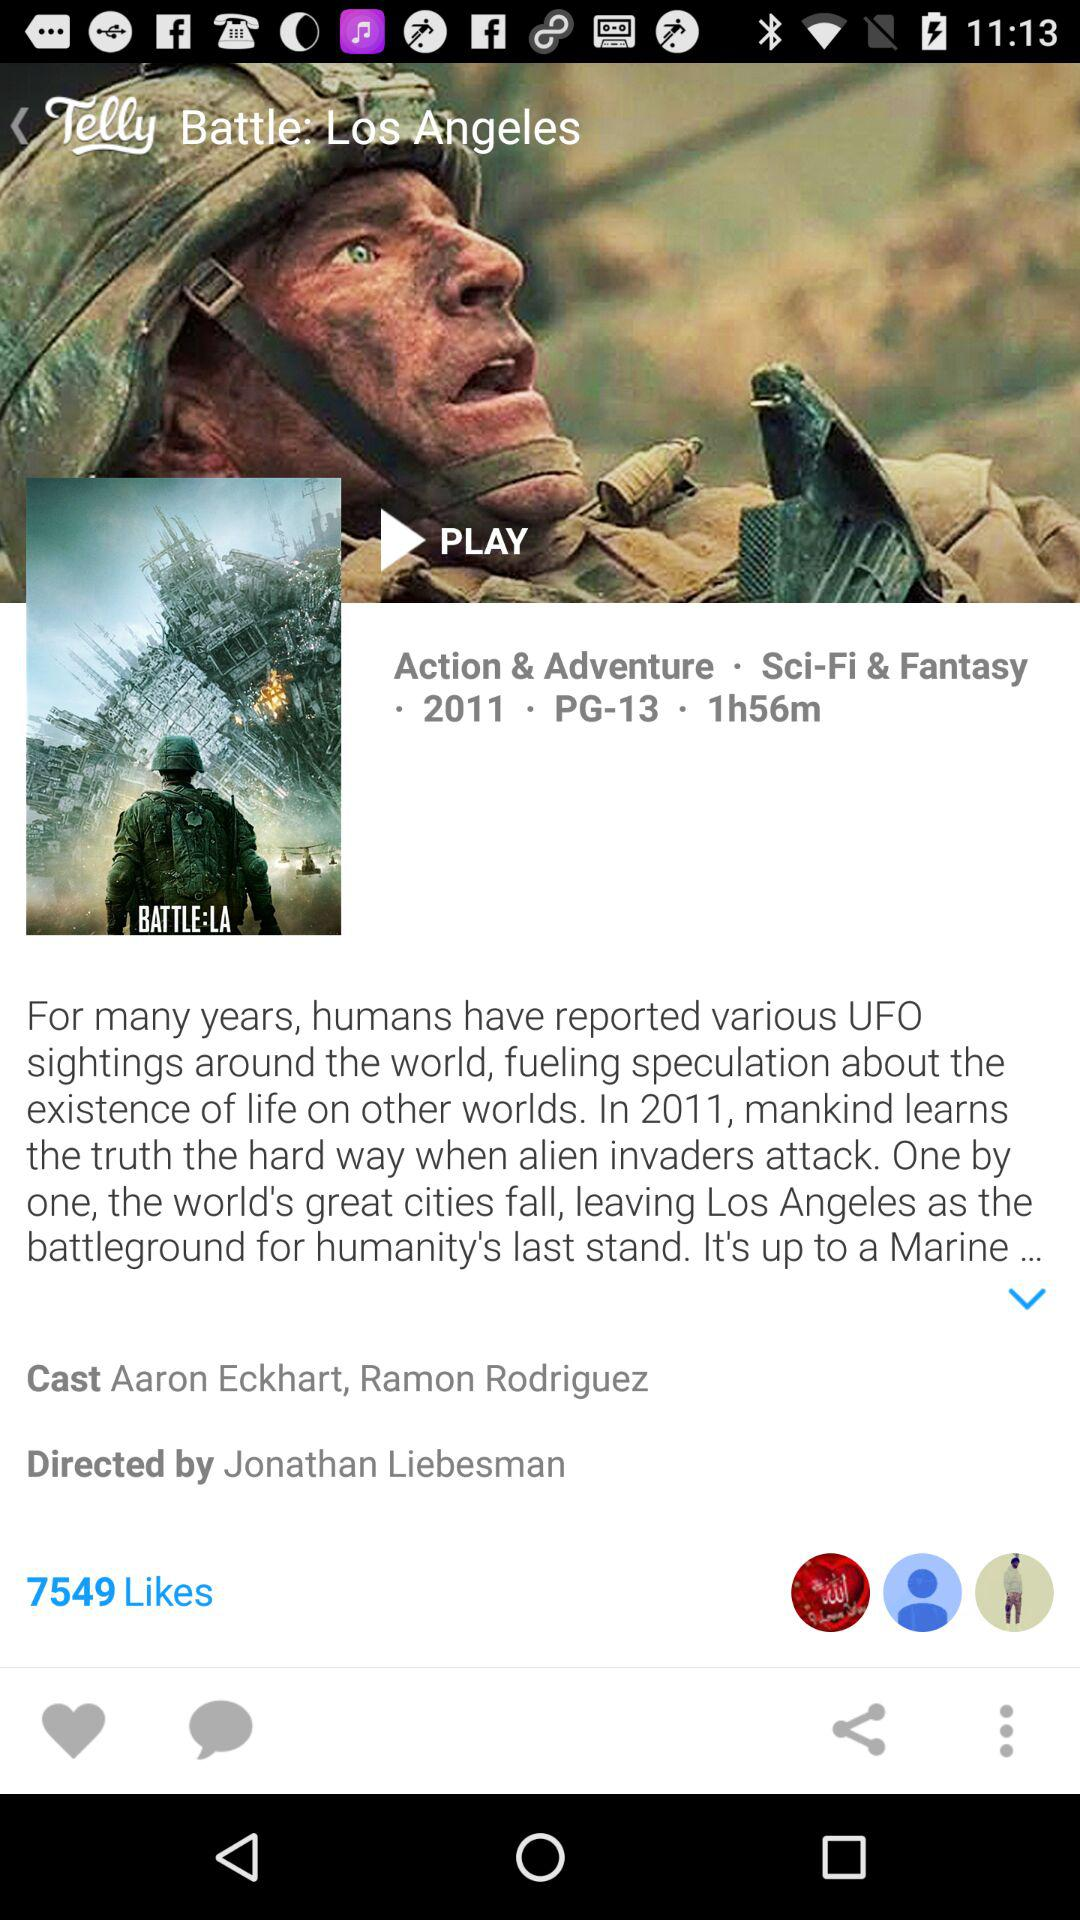What is the age rating of the movie?
When the provided information is insufficient, respond with <no answer>. <no answer> 